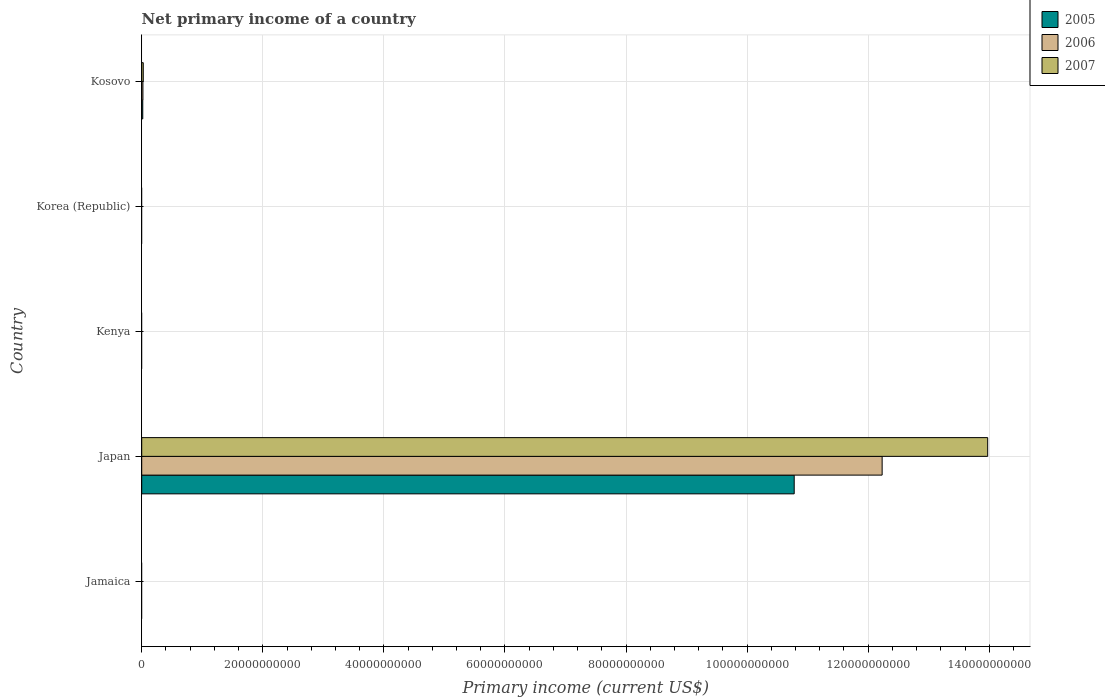Are the number of bars on each tick of the Y-axis equal?
Offer a very short reply. No. What is the label of the 5th group of bars from the top?
Your answer should be compact. Jamaica. Across all countries, what is the maximum primary income in 2006?
Your answer should be very brief. 1.22e+11. In which country was the primary income in 2006 maximum?
Make the answer very short. Japan. What is the total primary income in 2007 in the graph?
Keep it short and to the point. 1.40e+11. What is the difference between the primary income in 2007 in Kosovo and the primary income in 2006 in Jamaica?
Your response must be concise. 2.55e+08. What is the average primary income in 2006 per country?
Your answer should be compact. 2.45e+1. What is the difference between the primary income in 2006 and primary income in 2007 in Japan?
Ensure brevity in your answer.  -1.74e+1. What is the difference between the highest and the lowest primary income in 2005?
Your response must be concise. 1.08e+11. In how many countries, is the primary income in 2006 greater than the average primary income in 2006 taken over all countries?
Provide a short and direct response. 1. How many bars are there?
Your answer should be compact. 6. Are all the bars in the graph horizontal?
Make the answer very short. Yes. How many countries are there in the graph?
Ensure brevity in your answer.  5. What is the difference between two consecutive major ticks on the X-axis?
Your response must be concise. 2.00e+1. Are the values on the major ticks of X-axis written in scientific E-notation?
Your response must be concise. No. Does the graph contain any zero values?
Your answer should be very brief. Yes. Does the graph contain grids?
Offer a very short reply. Yes. Where does the legend appear in the graph?
Give a very brief answer. Top right. What is the title of the graph?
Your response must be concise. Net primary income of a country. What is the label or title of the X-axis?
Your answer should be very brief. Primary income (current US$). What is the Primary income (current US$) of 2006 in Jamaica?
Keep it short and to the point. 0. What is the Primary income (current US$) in 2007 in Jamaica?
Give a very brief answer. 0. What is the Primary income (current US$) in 2005 in Japan?
Make the answer very short. 1.08e+11. What is the Primary income (current US$) of 2006 in Japan?
Provide a succinct answer. 1.22e+11. What is the Primary income (current US$) of 2007 in Japan?
Make the answer very short. 1.40e+11. What is the Primary income (current US$) in 2005 in Kenya?
Provide a succinct answer. 0. What is the Primary income (current US$) of 2006 in Kenya?
Ensure brevity in your answer.  0. What is the Primary income (current US$) in 2007 in Kenya?
Make the answer very short. 0. What is the Primary income (current US$) in 2007 in Korea (Republic)?
Keep it short and to the point. 0. What is the Primary income (current US$) of 2005 in Kosovo?
Make the answer very short. 1.73e+08. What is the Primary income (current US$) in 2006 in Kosovo?
Offer a very short reply. 1.99e+08. What is the Primary income (current US$) of 2007 in Kosovo?
Your answer should be very brief. 2.55e+08. Across all countries, what is the maximum Primary income (current US$) of 2005?
Give a very brief answer. 1.08e+11. Across all countries, what is the maximum Primary income (current US$) of 2006?
Provide a succinct answer. 1.22e+11. Across all countries, what is the maximum Primary income (current US$) in 2007?
Offer a very short reply. 1.40e+11. Across all countries, what is the minimum Primary income (current US$) in 2005?
Make the answer very short. 0. Across all countries, what is the minimum Primary income (current US$) in 2006?
Your answer should be very brief. 0. What is the total Primary income (current US$) in 2005 in the graph?
Give a very brief answer. 1.08e+11. What is the total Primary income (current US$) in 2006 in the graph?
Provide a succinct answer. 1.23e+11. What is the total Primary income (current US$) of 2007 in the graph?
Give a very brief answer. 1.40e+11. What is the difference between the Primary income (current US$) in 2005 in Japan and that in Kosovo?
Keep it short and to the point. 1.08e+11. What is the difference between the Primary income (current US$) of 2006 in Japan and that in Kosovo?
Your response must be concise. 1.22e+11. What is the difference between the Primary income (current US$) in 2007 in Japan and that in Kosovo?
Your answer should be compact. 1.39e+11. What is the difference between the Primary income (current US$) of 2005 in Japan and the Primary income (current US$) of 2006 in Kosovo?
Ensure brevity in your answer.  1.08e+11. What is the difference between the Primary income (current US$) of 2005 in Japan and the Primary income (current US$) of 2007 in Kosovo?
Offer a terse response. 1.08e+11. What is the difference between the Primary income (current US$) in 2006 in Japan and the Primary income (current US$) in 2007 in Kosovo?
Keep it short and to the point. 1.22e+11. What is the average Primary income (current US$) in 2005 per country?
Keep it short and to the point. 2.16e+1. What is the average Primary income (current US$) of 2006 per country?
Provide a succinct answer. 2.45e+1. What is the average Primary income (current US$) in 2007 per country?
Offer a very short reply. 2.80e+1. What is the difference between the Primary income (current US$) in 2005 and Primary income (current US$) in 2006 in Japan?
Give a very brief answer. -1.45e+1. What is the difference between the Primary income (current US$) of 2005 and Primary income (current US$) of 2007 in Japan?
Give a very brief answer. -3.20e+1. What is the difference between the Primary income (current US$) of 2006 and Primary income (current US$) of 2007 in Japan?
Your response must be concise. -1.74e+1. What is the difference between the Primary income (current US$) in 2005 and Primary income (current US$) in 2006 in Kosovo?
Your answer should be compact. -2.62e+07. What is the difference between the Primary income (current US$) of 2005 and Primary income (current US$) of 2007 in Kosovo?
Offer a very short reply. -8.20e+07. What is the difference between the Primary income (current US$) of 2006 and Primary income (current US$) of 2007 in Kosovo?
Keep it short and to the point. -5.57e+07. What is the ratio of the Primary income (current US$) in 2005 in Japan to that in Kosovo?
Your answer should be very brief. 623.16. What is the ratio of the Primary income (current US$) in 2006 in Japan to that in Kosovo?
Make the answer very short. 614.04. What is the ratio of the Primary income (current US$) in 2007 in Japan to that in Kosovo?
Offer a terse response. 548.21. What is the difference between the highest and the lowest Primary income (current US$) in 2005?
Offer a terse response. 1.08e+11. What is the difference between the highest and the lowest Primary income (current US$) of 2006?
Give a very brief answer. 1.22e+11. What is the difference between the highest and the lowest Primary income (current US$) of 2007?
Your answer should be compact. 1.40e+11. 